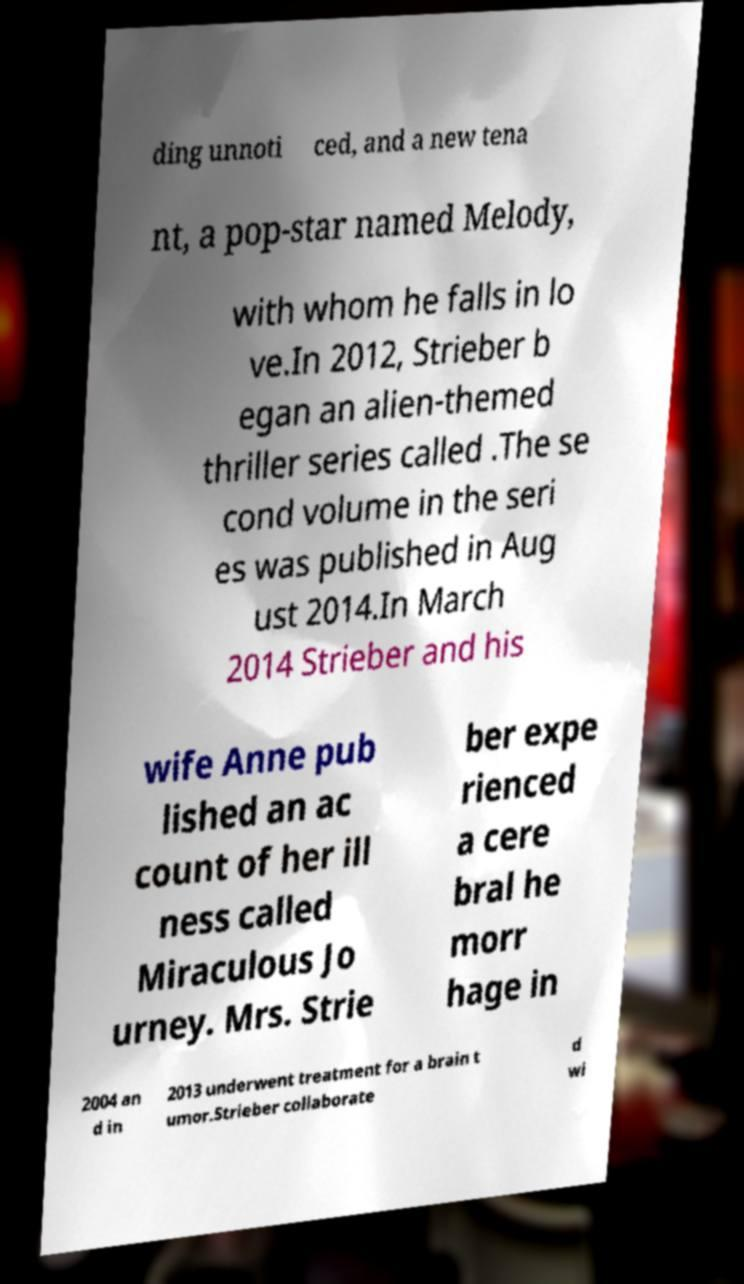I need the written content from this picture converted into text. Can you do that? ding unnoti ced, and a new tena nt, a pop-star named Melody, with whom he falls in lo ve.In 2012, Strieber b egan an alien-themed thriller series called .The se cond volume in the seri es was published in Aug ust 2014.In March 2014 Strieber and his wife Anne pub lished an ac count of her ill ness called Miraculous Jo urney. Mrs. Strie ber expe rienced a cere bral he morr hage in 2004 an d in 2013 underwent treatment for a brain t umor.Strieber collaborate d wi 